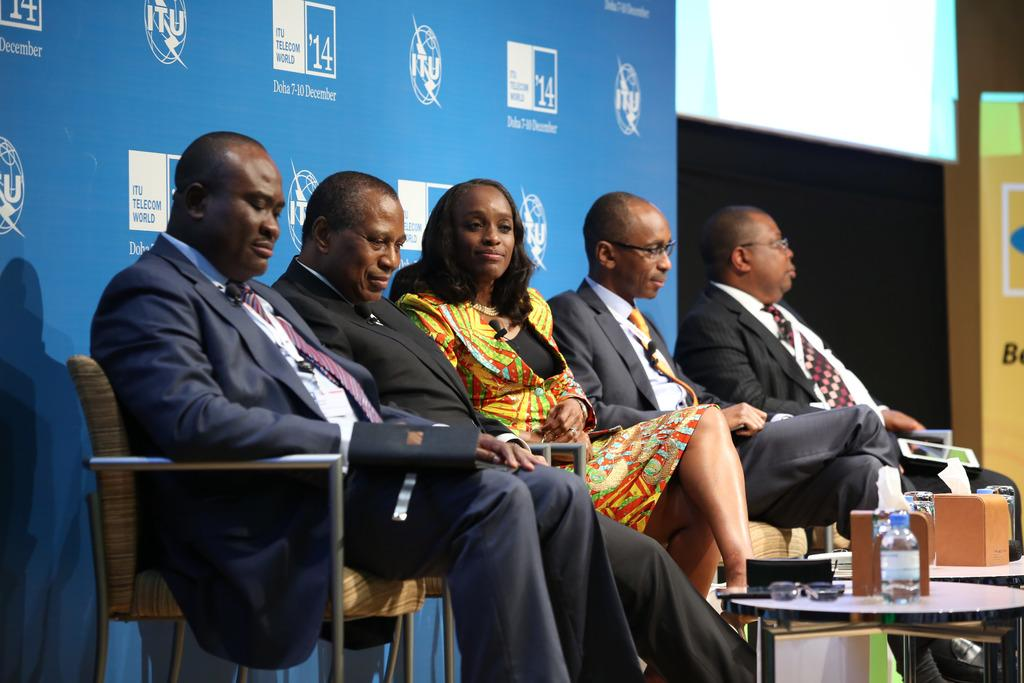What is happening in the image? There is a group of people in the image, and they are seated on chairs. What can be seen on the table in the image? There is a water bottle on a table in the image. What is visible in the background of the image? There is a hoarding visible in the background of the image. What type of rod is being used for the operation in the image? There is no operation or rod present in the image. What type of drink is being served to the people in the image? The only drink mentioned in the image is a water bottle, but the contents of the bottle are not specified. 